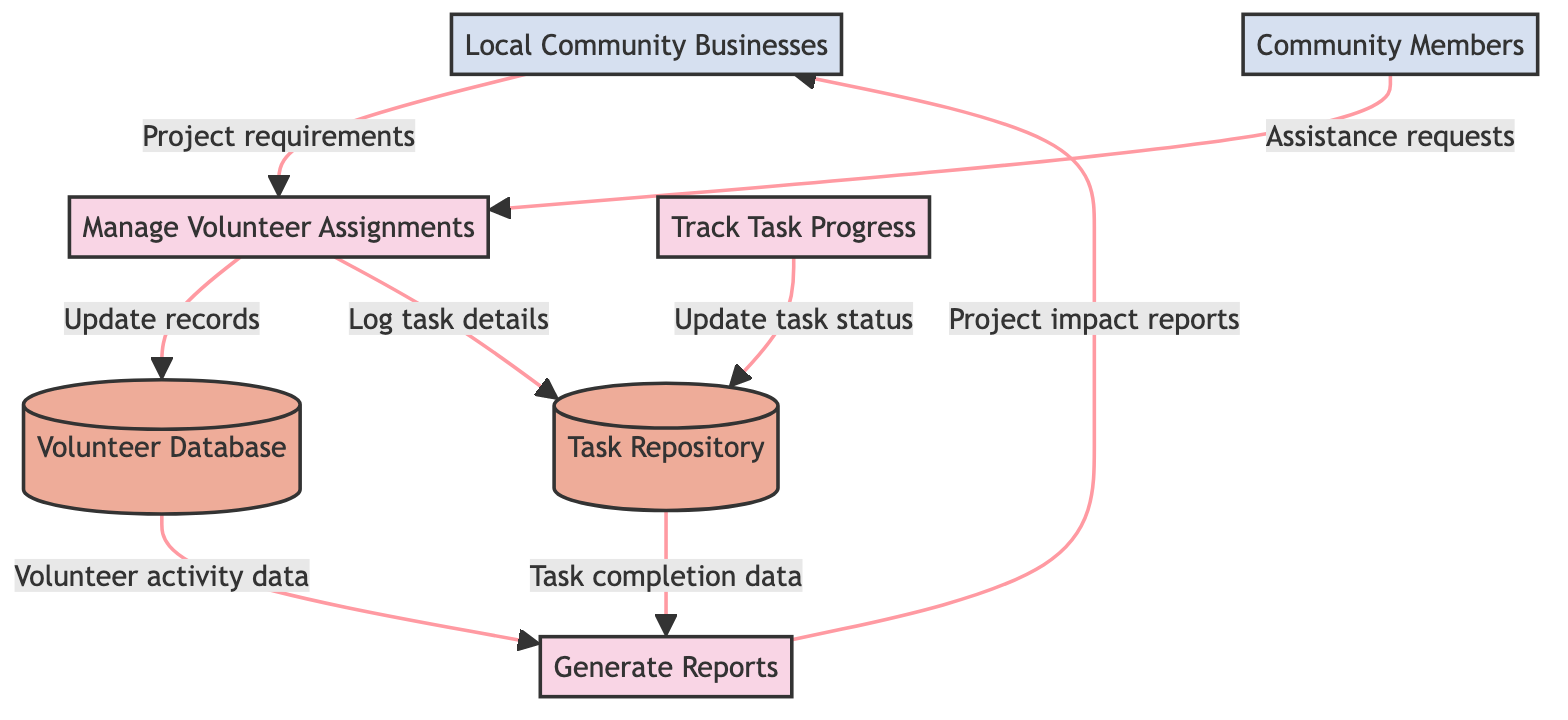What are the names of the external entities in the diagram? The diagram shows two external entities: "Local Community Businesses" and "Community Members."
Answer: Local Community Businesses, Community Members How many processes are present in the diagram? The diagram lists three processes: Manage Volunteer Assignments, Track Task Progress, and Generate Reports. Therefore, the total count is three.
Answer: 3 What does the "Manage Volunteer Assignments" process do? The process is described as coordinating and assigning volunteers to various community projects based on their skills and availability.
Answer: Coordinate and assign volunteers Which data store receives updates from the "Manage Volunteer Assignments" process? The "Volunteer Database" updates with new assignments and their statuses from the "Manage Volunteer Assignments" process.
Answer: Volunteer Database What type of data flows from the "Task Repository" to the "Generate Reports" process? The "Task Repository" provides data on task completion for report generation to the "Generate Reports" process.
Answer: Task completion data Which external entity provides project requirements to the "Manage Volunteer Assignments" process? The external entity identified as "Local Community Businesses" supplies project requirements to the "Manage Volunteer Assignments" process.
Answer: Local Community Businesses How many data stores are there in the diagram? There are three data stores: Volunteer Database, Task Repository, and Project Reports, totaling three data stores in the diagram.
Answer: 3 What is the outcome of the "Generate Reports" process towards the external entities? The process shares project impact reports and volunteer contributions with the "Local Community Businesses."
Answer: Project impact reports Which process updates the task status in the data store? The "Track Task Progress" process is responsible for updating task status in the "Task Repository" data store.
Answer: Track Task Progress 